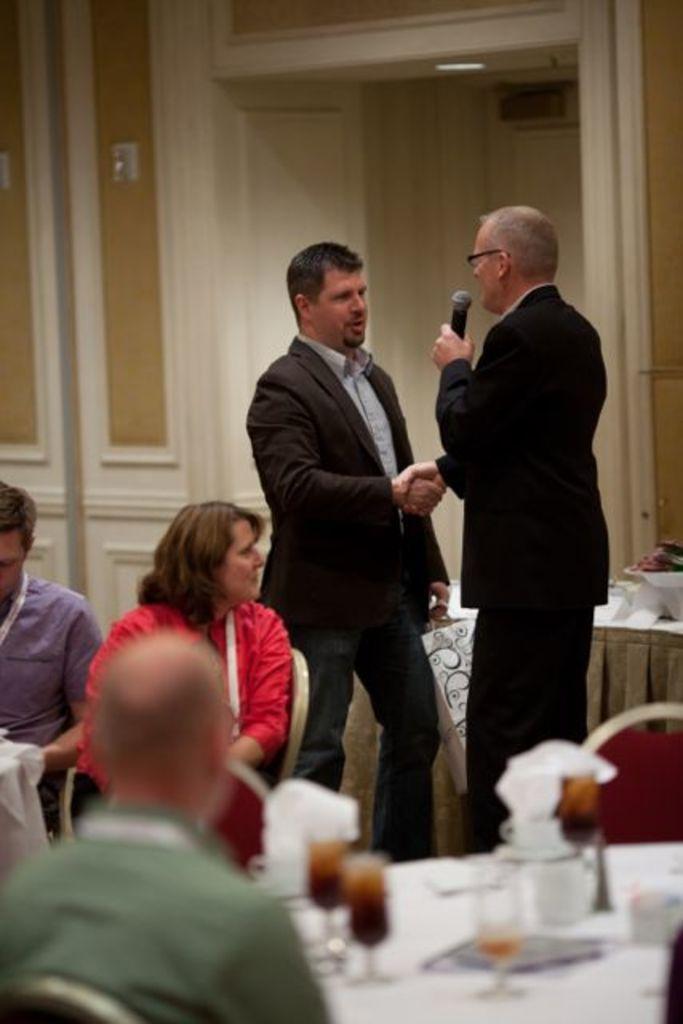In one or two sentences, can you explain what this image depicts? In this image we can see two men standing and three people sitting on chairs, the man on right side of the image is holding a microphone, we can also see tables in front, the table consist of two glasses and tissue papers, in the background we can see wooden wall, the persons standing in the background are shaking their hands. 